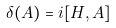<formula> <loc_0><loc_0><loc_500><loc_500>\delta ( A ) = i [ H , A ]</formula> 